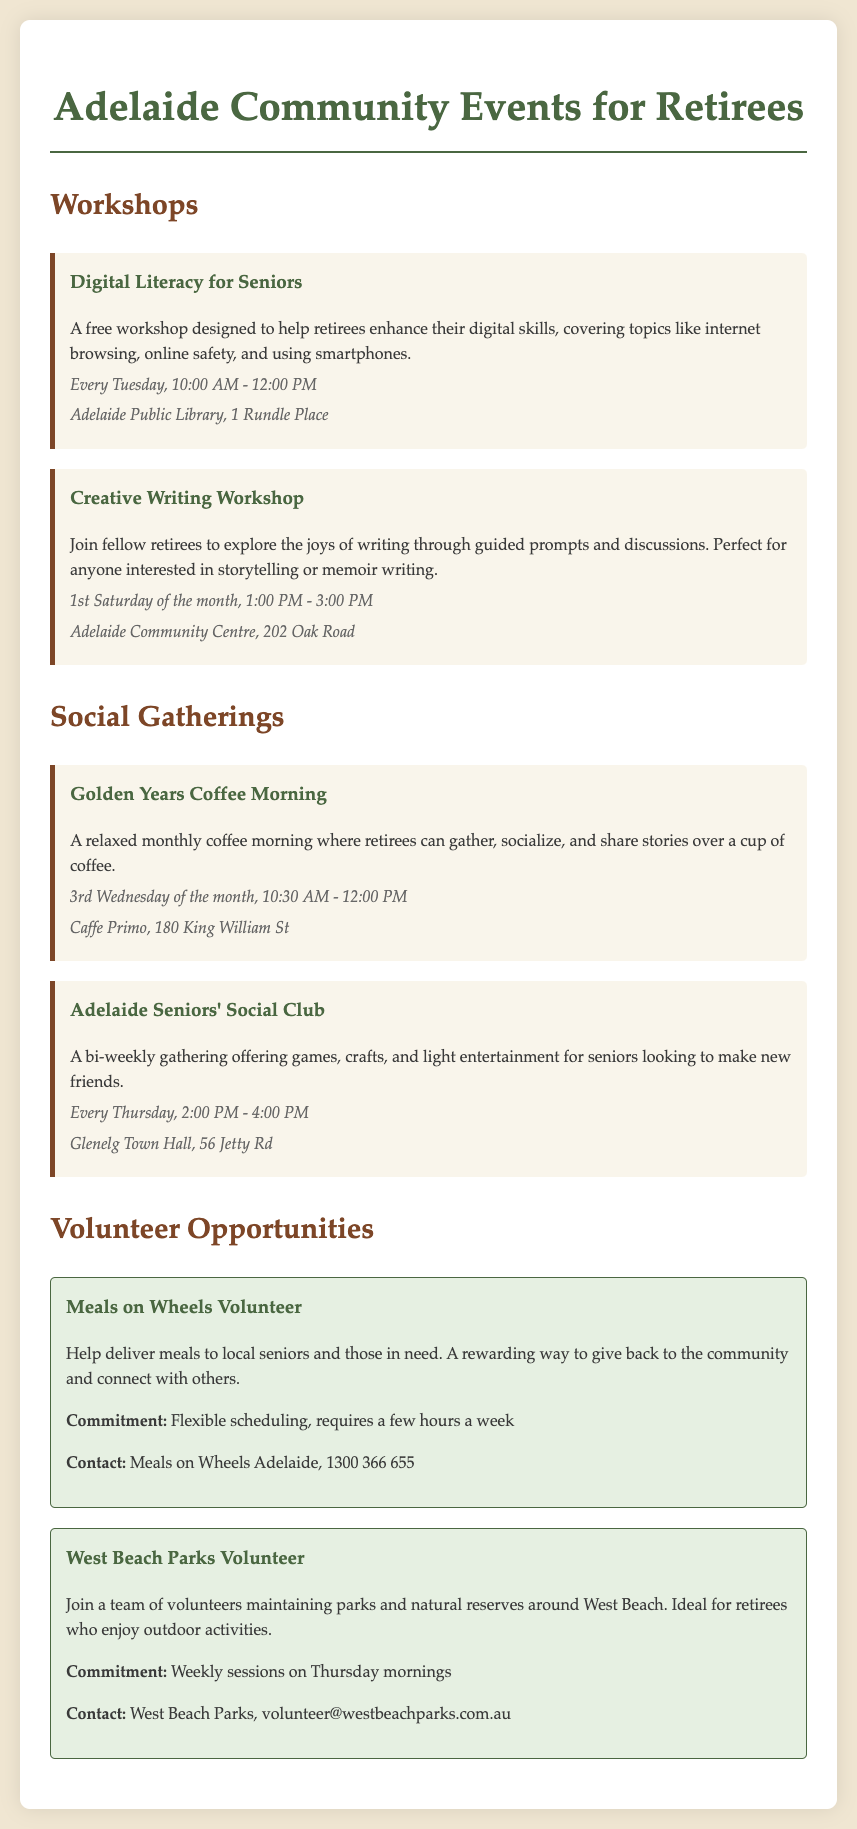What is the title of the first workshop? The title of the first workshop is the first event listed under the Workshops section.
Answer: Digital Literacy for Seniors When does the Creative Writing Workshop take place? The Creative Writing Workshop occurs on the first Saturday of the month from the event details.
Answer: 1st Saturday of the month, 1:00 PM - 3:00 PM Where is the Golden Years Coffee Morning held? The location for the Golden Years Coffee Morning is provided in the event details section.
Answer: Caffe Primo, 180 King William St How often is the Adelaide Seniors' Social Club held? The frequency of the Adelaide Seniors' Social Club is mentioned in the event description under Social Gatherings.
Answer: Every Thursday What is the commitment required for the West Beach Parks Volunteer opportunity? The commitment details for West Beach Parks Volunteer are provided in the event description under Volunteer Opportunities.
Answer: Weekly sessions on Thursday mornings Which workshop helps enhance digital skills? The workshop designed to help enhance digital skills is mentioned in the Workshops section.
Answer: Digital Literacy for Seniors What type of event is the Golden Years Coffee Morning? The Golden Years Coffee Morning is classified as a social gathering based on the section headings.
Answer: Social gathering What type of volunteer opportunity is Meals on Wheels? The type of volunteer opportunity is indicated in the description under Volunteer Opportunities.
Answer: Meals delivery 